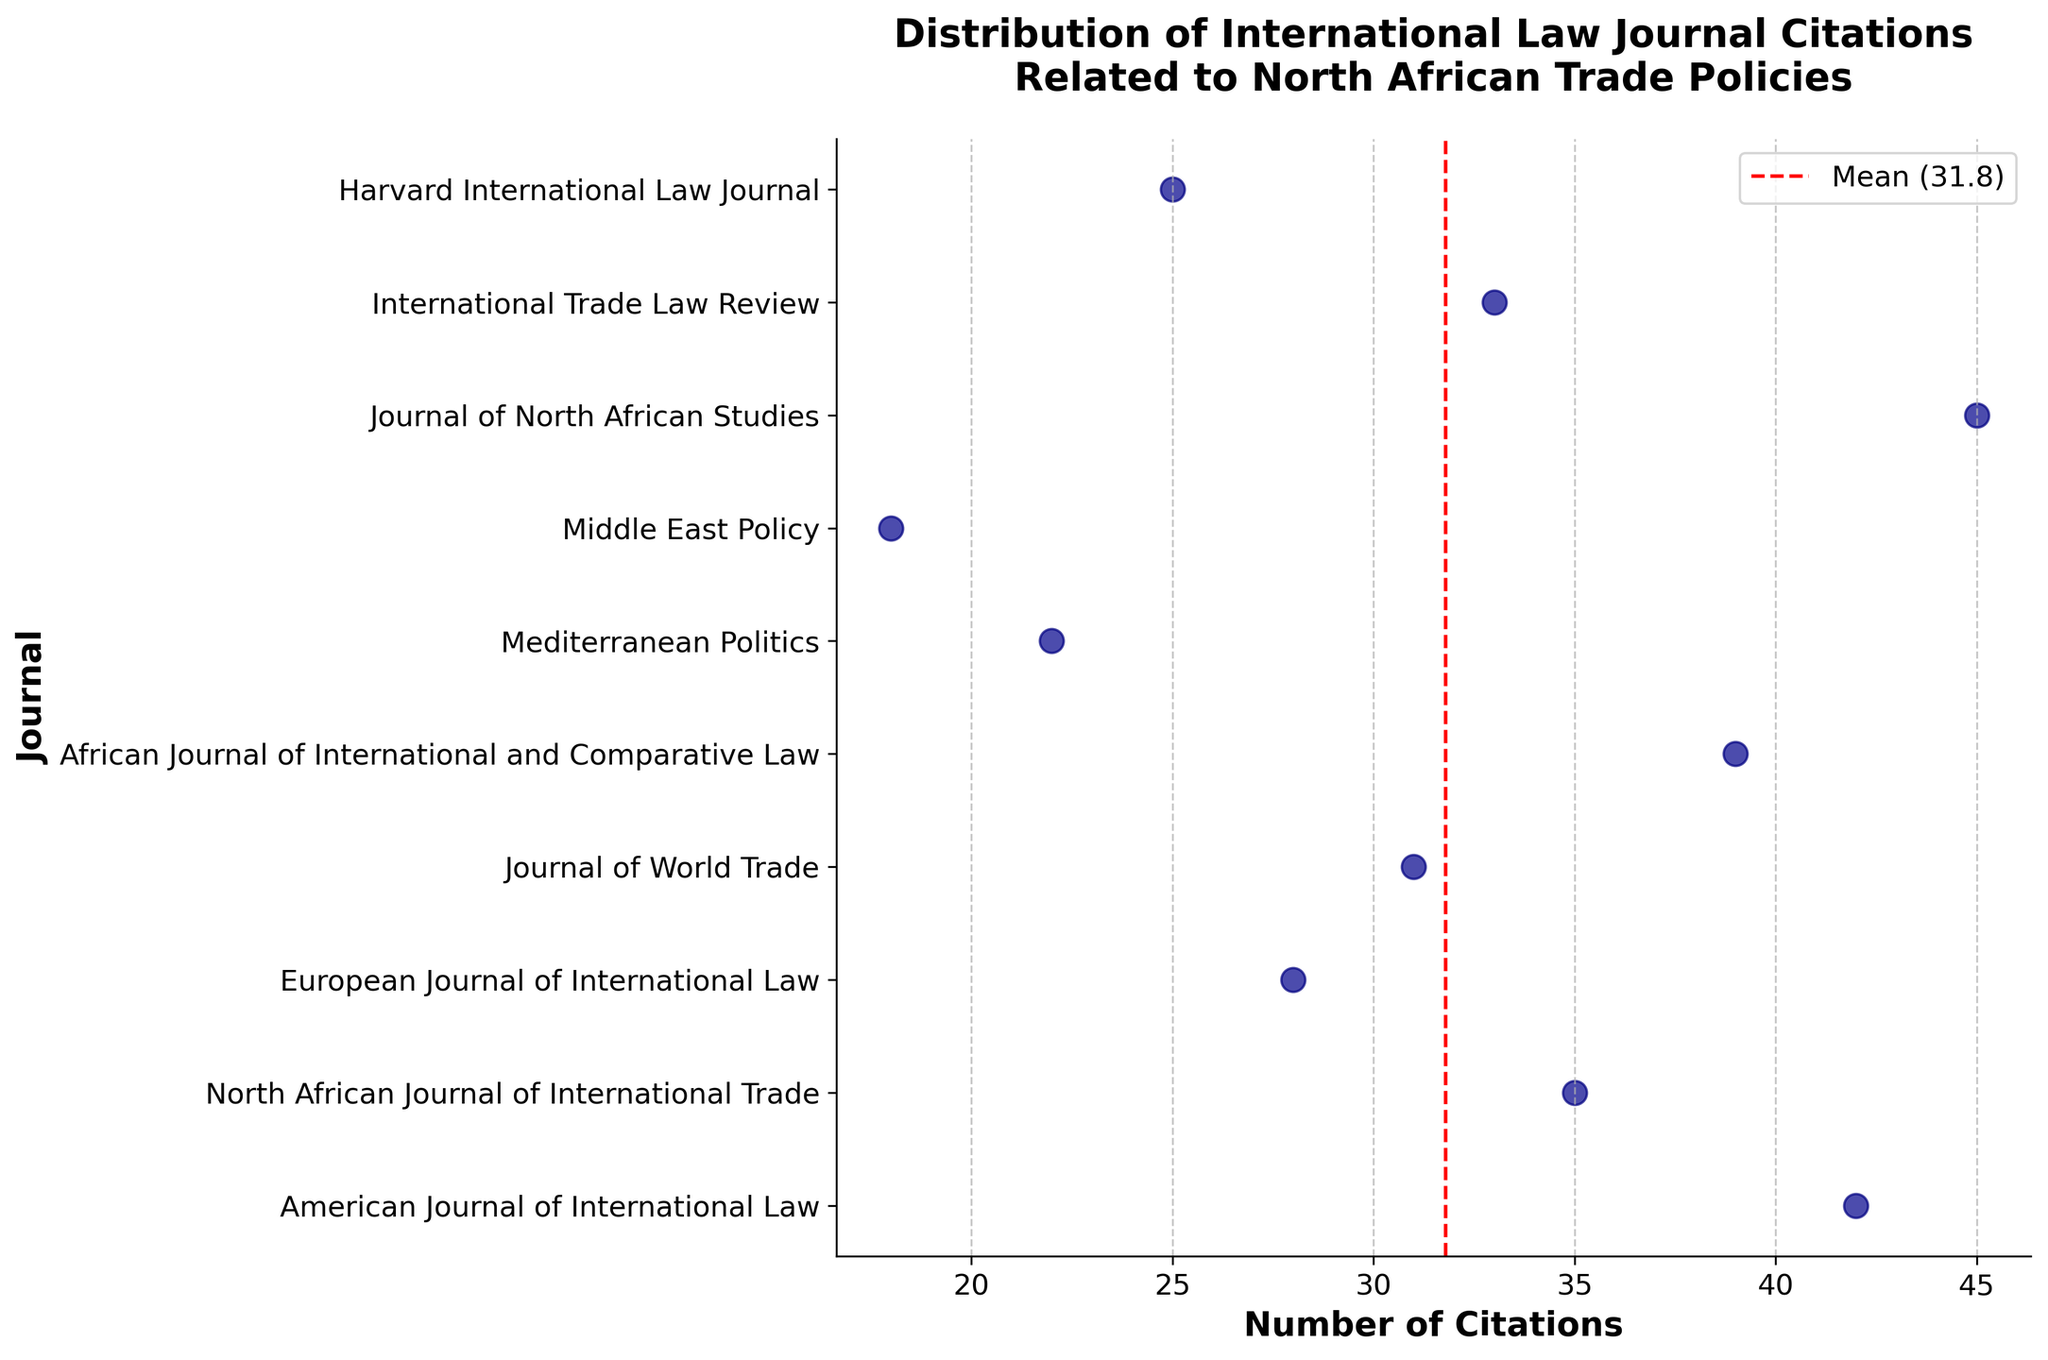What is the title of the figure? The title of the figure is located at the top and is usually in a larger or bold font to make it stand out. It provides an overview of what the figure is about. In this case, the title is "Distribution of International Law Journal Citations Related to North African Trade Policies."
Answer: Distribution of International Law Journal Citations Related to North African Trade Policies How many journals are displayed in the figure? The plot uses points to represent each journal. By counting the number of unique points (or labels on the y-axis), we can determine the number of journals. There are 10 journals listed on the y-axis.
Answer: 10 Which journal has the highest number of citations? By observing the strip plot, the journal with the point farthest to the right will represent the highest number of citations. In this plot, it is the Journal of North African Studies with 45 citations.
Answer: Journal of North African Studies What does the red dashed line represent? The red dashed line is a visual cue that typically represents an average or mean value in a plot. In this case, the label next to the line specifies that it represents the mean number of citations, which is 31.8.
Answer: Mean number of citations What journal has the lowest number of citations? The journal with the point farthest to the left on the plot will have the lowest number of citations. The point at 18 citations corresponds to the journal Middle East Policy.
Answer: Middle East Policy How many journals have more than 30 citations? To determine this, count the number of points that are positioned to the right of the 30 citation mark on the x-axis. By visual inspection, five journals have more than 30 citations. These are American Journal of International Law, North African Journal of International Trade, African Journal of International and Comparative Law, Journal of North African Studies, and International Trade Law Review.
Answer: Five What is the range of citations in the plot? The range is calculated by subtracting the lowest number of citations from the highest number of citations. The highest is 45 citations (Journal of North African Studies), and the lowest is 18 citations (Middle East Policy), making the range 45 - 18 = 27.
Answer: 27 What is the average number of citations? The red dashed line in the plot denotes the mean of the citations, as indicated in the legend. The average number of citations is 31.8.
Answer: 31.8 Which journal's citation count is closest to the mean number of citations? To answer this, find the journal's citation value closest to 31.8 and identify the corresponding journal. The International Trade Law Review has 33 citations, which is closest to the mean.
Answer: International Trade Law Review How does the European Journal of International Law compare to the American Journal of International Law in terms of citations? To determine this, compare the locations of the points representing these two journals on the x-axis. The American Journal of International Law has 42 citations, while the European Journal of International Law has 28 citations. Therefore, the American Journal of International Law has more citations.
Answer: The American Journal of International Law has more citations 